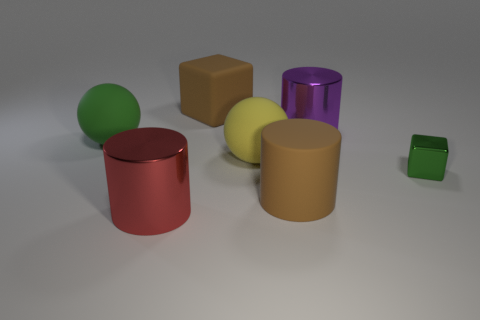Are there any big green matte balls behind the big red shiny cylinder that is in front of the rubber block?
Offer a very short reply. Yes. Does the yellow rubber object have the same shape as the green thing to the left of the matte cylinder?
Give a very brief answer. Yes. There is a big shiny thing behind the yellow sphere; what color is it?
Provide a succinct answer. Purple. There is a red metal cylinder to the left of the big matte object that is behind the large green object; how big is it?
Offer a terse response. Large. Does the brown thing that is in front of the large purple cylinder have the same shape as the green rubber thing?
Your answer should be very brief. No. There is another object that is the same shape as the green metal thing; what is its material?
Offer a very short reply. Rubber. What number of things are either large matte objects that are behind the big green rubber ball or large metallic cylinders behind the big yellow rubber ball?
Provide a succinct answer. 2. There is a big matte cylinder; is its color the same as the large object that is behind the big purple metallic thing?
Keep it short and to the point. Yes. What shape is the yellow thing that is the same material as the green sphere?
Make the answer very short. Sphere. How many big cylinders are there?
Give a very brief answer. 3. 